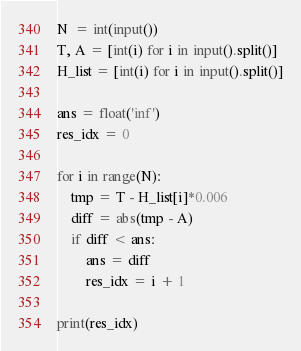<code> <loc_0><loc_0><loc_500><loc_500><_Python_>N  = int(input())
T, A = [int(i) for i in input().split()]
H_list = [int(i) for i in input().split()]

ans = float('inf')
res_idx = 0

for i in range(N):  
    tmp = T - H_list[i]*0.006
    diff = abs(tmp - A)
    if diff < ans:
        ans = diff
        res_idx = i + 1
        
print(res_idx)</code> 